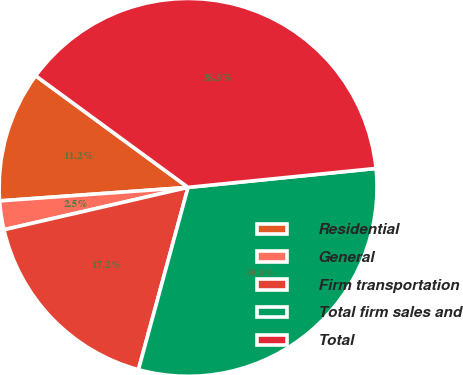Convert chart. <chart><loc_0><loc_0><loc_500><loc_500><pie_chart><fcel>Residential<fcel>General<fcel>Firm transportation<fcel>Total firm sales and<fcel>Total<nl><fcel>11.2%<fcel>2.46%<fcel>17.17%<fcel>30.83%<fcel>38.34%<nl></chart> 